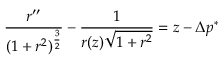<formula> <loc_0><loc_0><loc_500><loc_500>{ \frac { r ^ { \prime \prime } } { ( 1 + r ^ { 2 } ) ^ { \frac { 3 } { 2 } } } } - { \frac { 1 } { r ( z ) { \sqrt { 1 + r ^ { 2 } } } } } = z - \Delta p ^ { * }</formula> 